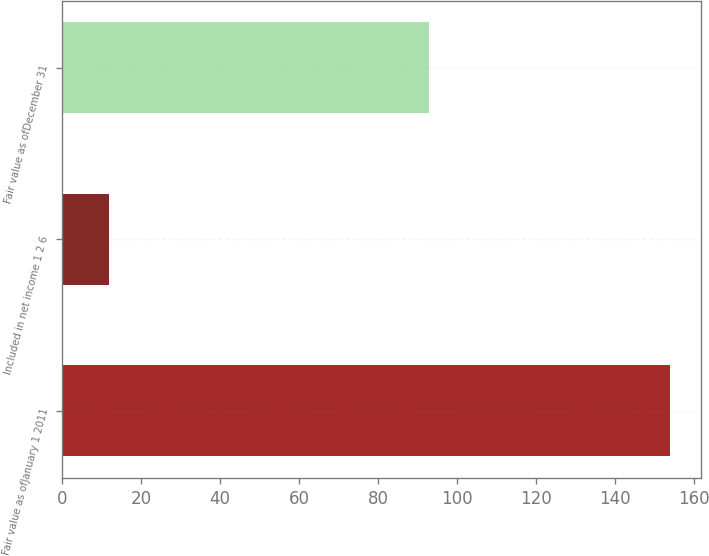Convert chart. <chart><loc_0><loc_0><loc_500><loc_500><bar_chart><fcel>Fair value as ofJanuary 1 2011<fcel>Included in net income 1 2 6<fcel>Fair value as ofDecember 31<nl><fcel>154<fcel>12<fcel>93<nl></chart> 